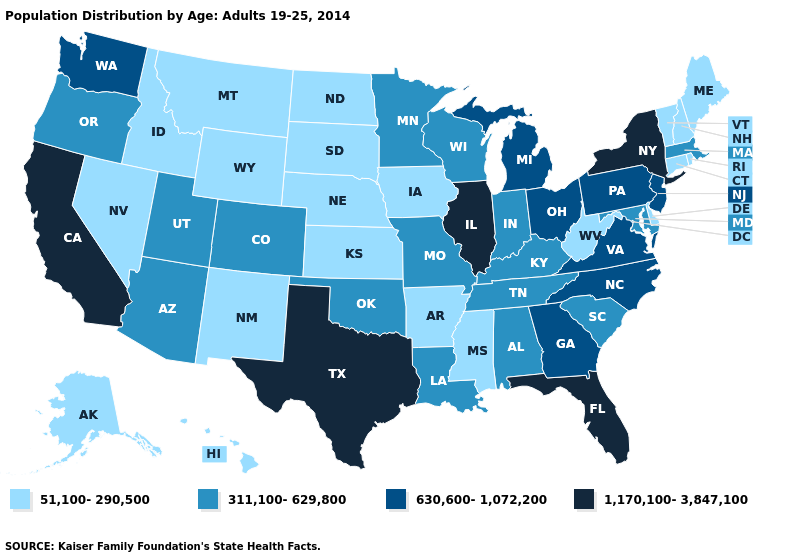Does Illinois have the highest value in the USA?
Short answer required. Yes. Does New York have the lowest value in the USA?
Give a very brief answer. No. What is the highest value in the USA?
Answer briefly. 1,170,100-3,847,100. Does Delaware have the lowest value in the South?
Concise answer only. Yes. Name the states that have a value in the range 1,170,100-3,847,100?
Give a very brief answer. California, Florida, Illinois, New York, Texas. Which states have the lowest value in the USA?
Concise answer only. Alaska, Arkansas, Connecticut, Delaware, Hawaii, Idaho, Iowa, Kansas, Maine, Mississippi, Montana, Nebraska, Nevada, New Hampshire, New Mexico, North Dakota, Rhode Island, South Dakota, Vermont, West Virginia, Wyoming. Which states have the lowest value in the MidWest?
Keep it brief. Iowa, Kansas, Nebraska, North Dakota, South Dakota. What is the value of North Carolina?
Give a very brief answer. 630,600-1,072,200. Name the states that have a value in the range 51,100-290,500?
Be succinct. Alaska, Arkansas, Connecticut, Delaware, Hawaii, Idaho, Iowa, Kansas, Maine, Mississippi, Montana, Nebraska, Nevada, New Hampshire, New Mexico, North Dakota, Rhode Island, South Dakota, Vermont, West Virginia, Wyoming. Name the states that have a value in the range 630,600-1,072,200?
Quick response, please. Georgia, Michigan, New Jersey, North Carolina, Ohio, Pennsylvania, Virginia, Washington. Name the states that have a value in the range 51,100-290,500?
Be succinct. Alaska, Arkansas, Connecticut, Delaware, Hawaii, Idaho, Iowa, Kansas, Maine, Mississippi, Montana, Nebraska, Nevada, New Hampshire, New Mexico, North Dakota, Rhode Island, South Dakota, Vermont, West Virginia, Wyoming. Is the legend a continuous bar?
Give a very brief answer. No. Name the states that have a value in the range 311,100-629,800?
Concise answer only. Alabama, Arizona, Colorado, Indiana, Kentucky, Louisiana, Maryland, Massachusetts, Minnesota, Missouri, Oklahoma, Oregon, South Carolina, Tennessee, Utah, Wisconsin. Which states have the highest value in the USA?
Concise answer only. California, Florida, Illinois, New York, Texas. 